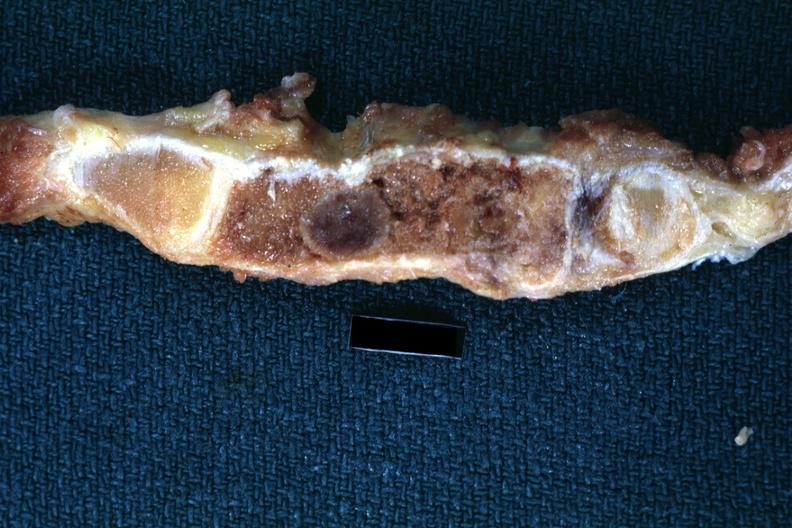s saggital section sternum with typical plasmacytoma shown close-up very good?
Answer the question using a single word or phrase. Yes 